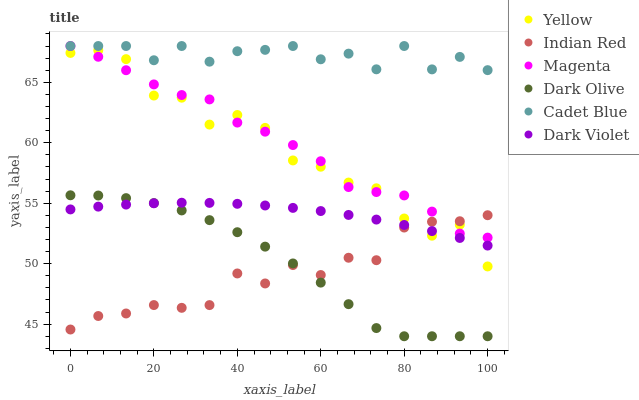Does Indian Red have the minimum area under the curve?
Answer yes or no. Yes. Does Cadet Blue have the maximum area under the curve?
Answer yes or no. Yes. Does Dark Olive have the minimum area under the curve?
Answer yes or no. No. Does Dark Olive have the maximum area under the curve?
Answer yes or no. No. Is Dark Violet the smoothest?
Answer yes or no. Yes. Is Yellow the roughest?
Answer yes or no. Yes. Is Dark Olive the smoothest?
Answer yes or no. No. Is Dark Olive the roughest?
Answer yes or no. No. Does Dark Olive have the lowest value?
Answer yes or no. Yes. Does Dark Violet have the lowest value?
Answer yes or no. No. Does Magenta have the highest value?
Answer yes or no. Yes. Does Dark Olive have the highest value?
Answer yes or no. No. Is Dark Violet less than Cadet Blue?
Answer yes or no. Yes. Is Magenta greater than Dark Violet?
Answer yes or no. Yes. Does Yellow intersect Dark Violet?
Answer yes or no. Yes. Is Yellow less than Dark Violet?
Answer yes or no. No. Is Yellow greater than Dark Violet?
Answer yes or no. No. Does Dark Violet intersect Cadet Blue?
Answer yes or no. No. 